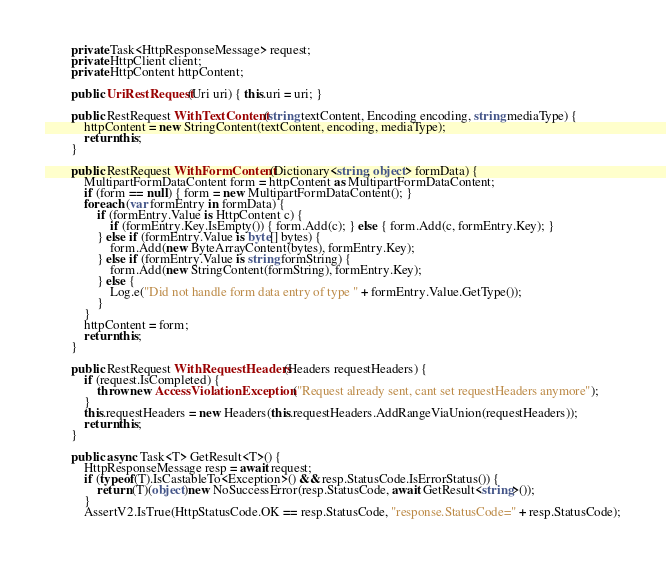<code> <loc_0><loc_0><loc_500><loc_500><_C#_>        private Task<HttpResponseMessage> request;
        private HttpClient client;
        private HttpContent httpContent;

        public UriRestRequest(Uri uri) { this.uri = uri; }

        public RestRequest WithTextContent(string textContent, Encoding encoding, string mediaType) {
            httpContent = new StringContent(textContent, encoding, mediaType);
            return this;
        }

        public RestRequest WithFormContent(Dictionary<string, object> formData) {
            MultipartFormDataContent form = httpContent as MultipartFormDataContent;
            if (form == null) { form = new MultipartFormDataContent(); }
            foreach (var formEntry in formData) {
                if (formEntry.Value is HttpContent c) {
                    if (formEntry.Key.IsEmpty()) { form.Add(c); } else { form.Add(c, formEntry.Key); }
                } else if (formEntry.Value is byte[] bytes) {
                    form.Add(new ByteArrayContent(bytes), formEntry.Key);
                } else if (formEntry.Value is string formString) {
                    form.Add(new StringContent(formString), formEntry.Key);
                } else {
                    Log.e("Did not handle form data entry of type " + formEntry.Value.GetType());
                }
            }
            httpContent = form;
            return this;
        }

        public RestRequest WithRequestHeaders(Headers requestHeaders) {
            if (request.IsCompleted) {
                throw new AccessViolationException("Request already sent, cant set requestHeaders anymore");
            }
            this.requestHeaders = new Headers(this.requestHeaders.AddRangeViaUnion(requestHeaders));
            return this;
        }

        public async Task<T> GetResult<T>() {
            HttpResponseMessage resp = await request;
            if (typeof(T).IsCastableTo<Exception>() && resp.StatusCode.IsErrorStatus()) {
                return (T)(object)new NoSuccessError(resp.StatusCode, await GetResult<string>());
            }
            AssertV2.IsTrue(HttpStatusCode.OK == resp.StatusCode, "response.StatusCode=" + resp.StatusCode);</code> 